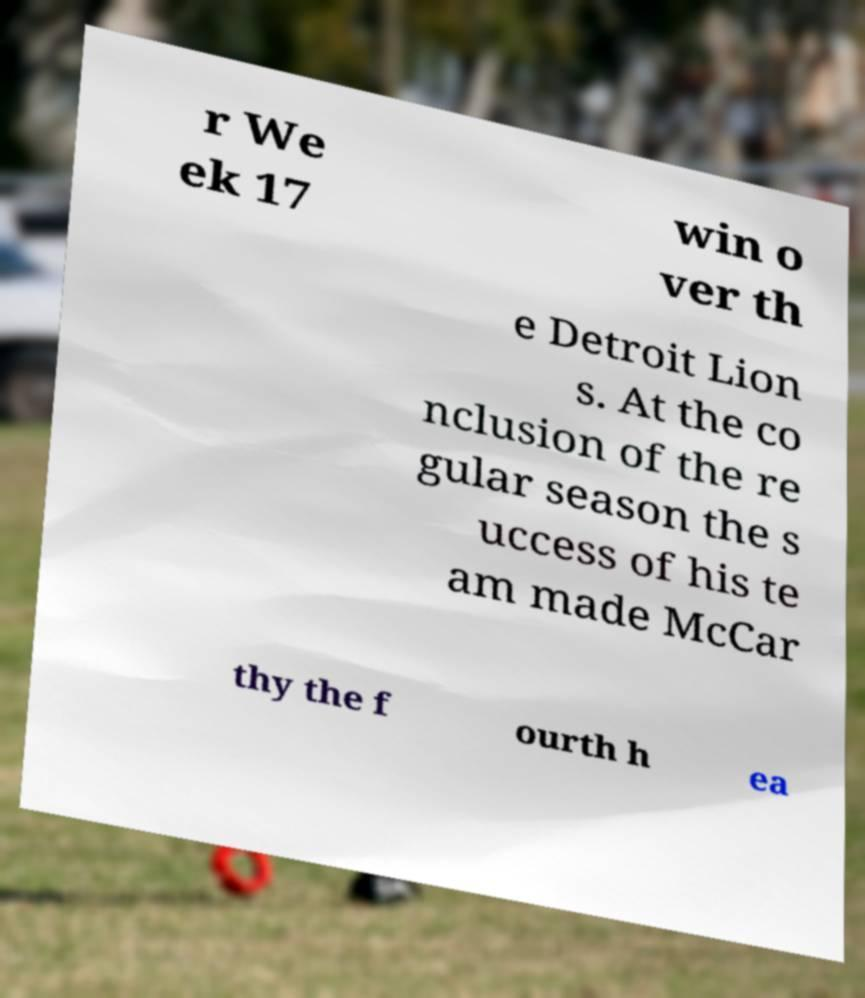What messages or text are displayed in this image? I need them in a readable, typed format. r We ek 17 win o ver th e Detroit Lion s. At the co nclusion of the re gular season the s uccess of his te am made McCar thy the f ourth h ea 